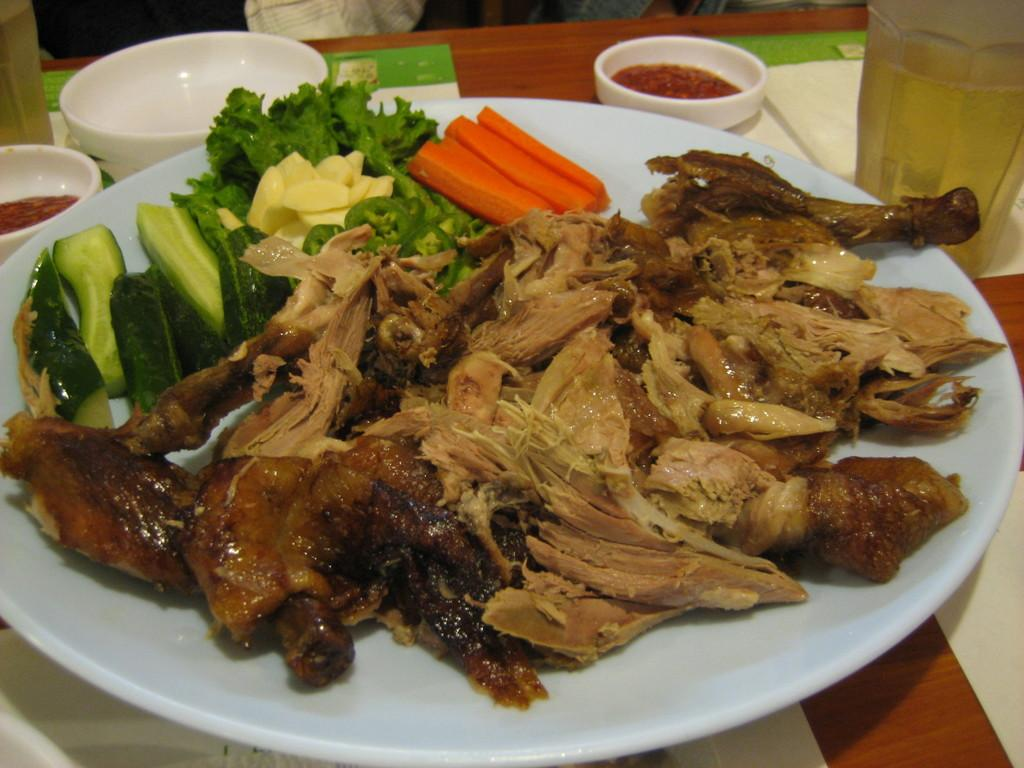What is on the plate that is visible in the image? There is a plate with food items in the image. What else can be seen on the table in the image? There are objects on the table in the image. What type of grip does the cracker have in the image? There is no cracker present in the image, so it is not possible to determine its grip. 